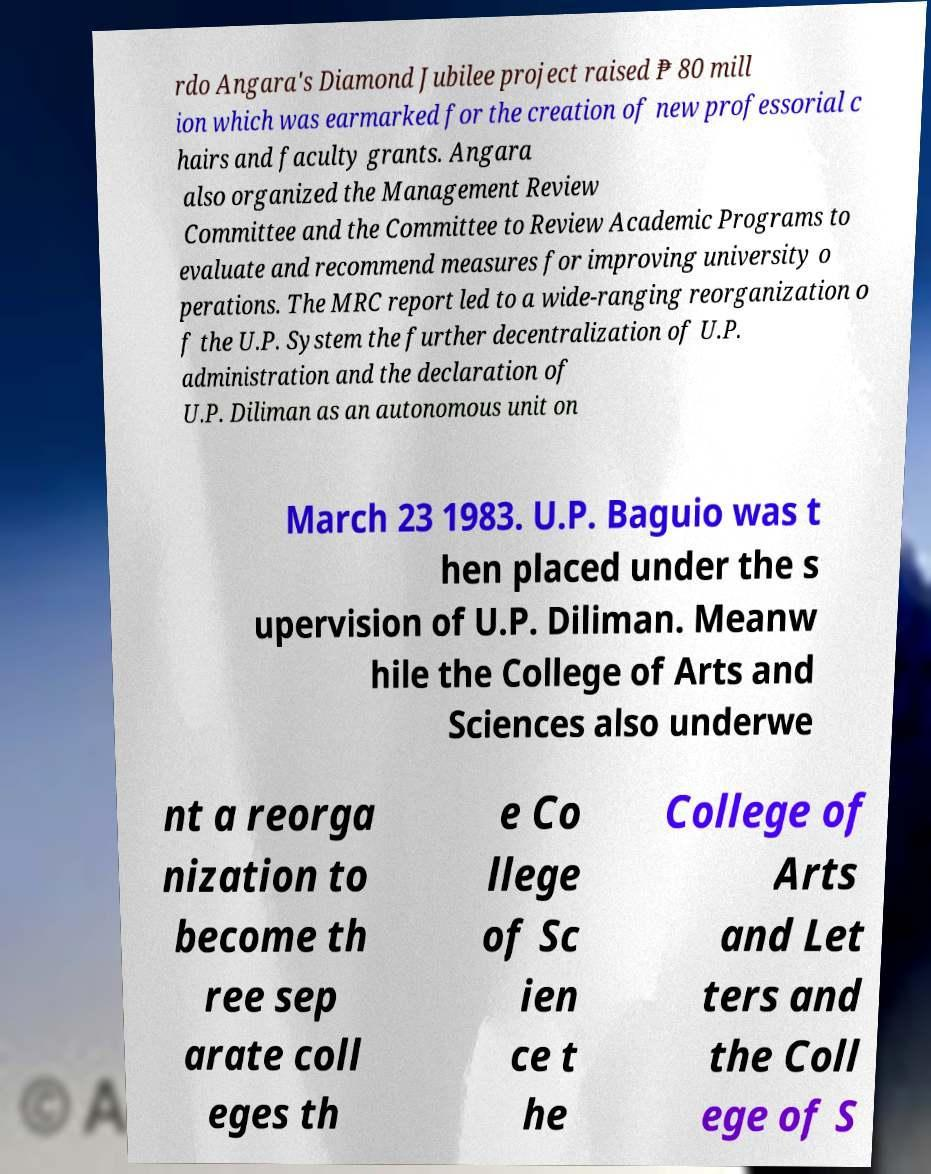Could you assist in decoding the text presented in this image and type it out clearly? rdo Angara's Diamond Jubilee project raised ₱ 80 mill ion which was earmarked for the creation of new professorial c hairs and faculty grants. Angara also organized the Management Review Committee and the Committee to Review Academic Programs to evaluate and recommend measures for improving university o perations. The MRC report led to a wide-ranging reorganization o f the U.P. System the further decentralization of U.P. administration and the declaration of U.P. Diliman as an autonomous unit on March 23 1983. U.P. Baguio was t hen placed under the s upervision of U.P. Diliman. Meanw hile the College of Arts and Sciences also underwe nt a reorga nization to become th ree sep arate coll eges th e Co llege of Sc ien ce t he College of Arts and Let ters and the Coll ege of S 